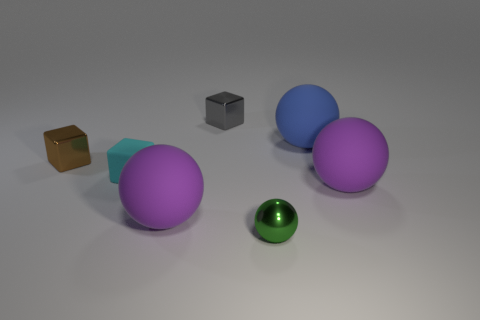Subtract all large matte spheres. How many spheres are left? 1 Subtract all brown cubes. How many cubes are left? 2 Add 2 gray metal objects. How many objects exist? 9 Subtract all purple cubes. How many purple spheres are left? 2 Subtract all spheres. How many objects are left? 3 Add 5 big matte spheres. How many big matte spheres are left? 8 Add 3 big blue objects. How many big blue objects exist? 4 Subtract 0 green blocks. How many objects are left? 7 Subtract all brown spheres. Subtract all brown cylinders. How many spheres are left? 4 Subtract all purple objects. Subtract all small cyan rubber objects. How many objects are left? 4 